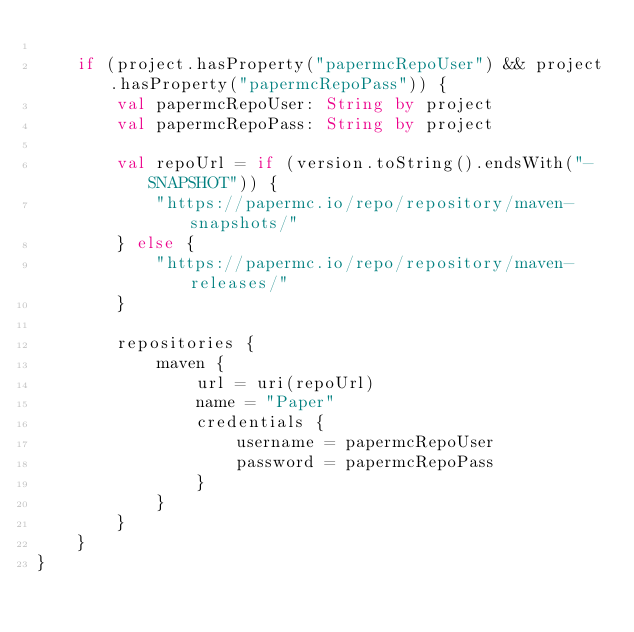<code> <loc_0><loc_0><loc_500><loc_500><_Kotlin_>
    if (project.hasProperty("papermcRepoUser") && project.hasProperty("papermcRepoPass")) {
        val papermcRepoUser: String by project
        val papermcRepoPass: String by project

        val repoUrl = if (version.toString().endsWith("-SNAPSHOT")) {
            "https://papermc.io/repo/repository/maven-snapshots/"
        } else {
            "https://papermc.io/repo/repository/maven-releases/"
        }

        repositories {
            maven {
                url = uri(repoUrl)
                name = "Paper"
                credentials {
                    username = papermcRepoUser
                    password = papermcRepoPass
                }
            }
        }
    }
}
</code> 